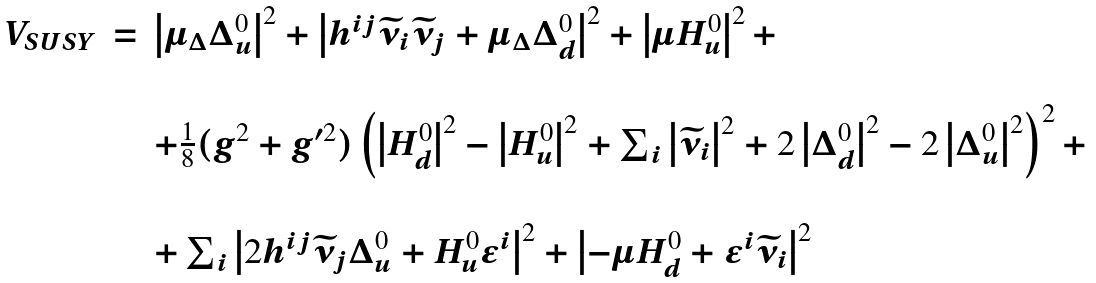Convert formula to latex. <formula><loc_0><loc_0><loc_500><loc_500>\begin{array} { c c l } V _ { S U S Y } & = & \left | \mu _ { \Delta } \Delta _ { u } ^ { 0 } \right | ^ { 2 } + \left | h ^ { i j } \widetilde { \nu } _ { i } \widetilde { \nu } _ { j } + \mu _ { \Delta } \Delta _ { d } ^ { 0 } \right | ^ { 2 } + \left | \mu H _ { u } ^ { 0 } \right | ^ { 2 } + \\ & & \\ & & + \frac { 1 } { 8 } ( g ^ { 2 } + g ^ { \prime 2 } ) \left ( \left | H _ { d } ^ { 0 } \right | ^ { 2 } - \left | H _ { u } ^ { 0 } \right | ^ { 2 } + \sum _ { i } \left | \widetilde { \nu } _ { i } \right | ^ { 2 } + 2 \left | \Delta _ { d } ^ { 0 } \right | ^ { 2 } - 2 \left | \Delta _ { u } ^ { 0 } \right | ^ { 2 } \right ) ^ { 2 } + \\ & & \\ & & + \sum _ { i } \left | 2 h ^ { i j } \widetilde { \nu } _ { j } \Delta _ { u } ^ { 0 } + H _ { u } ^ { 0 } \epsilon ^ { i } \right | ^ { 2 } + \left | - \mu H _ { d } ^ { 0 } + \epsilon ^ { i } \widetilde { \nu } _ { i } \right | ^ { 2 } \end{array}</formula> 